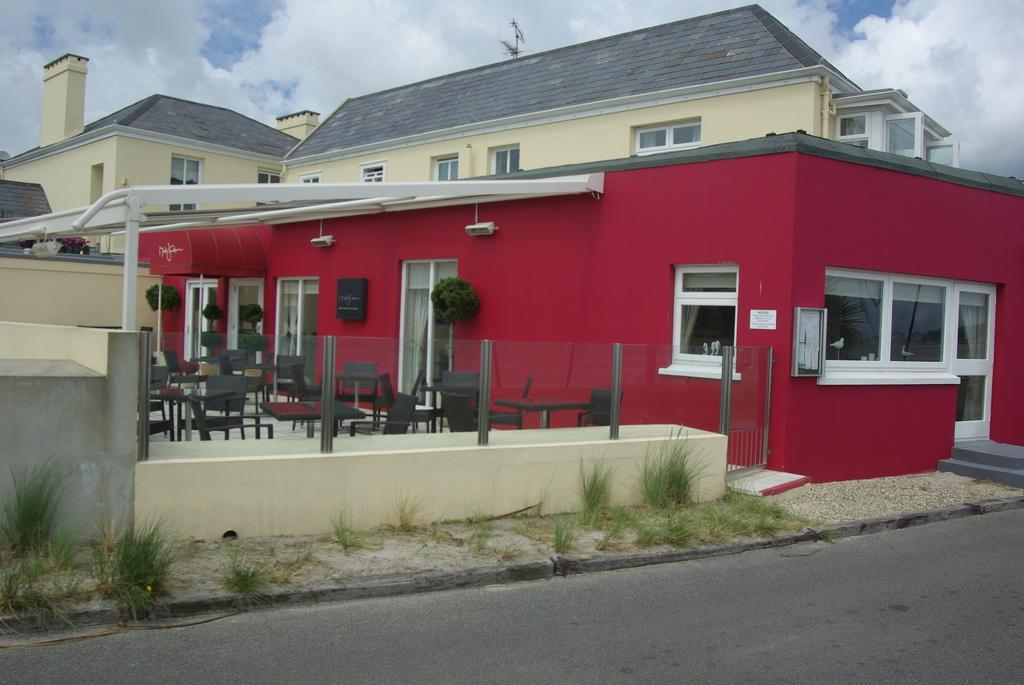What is the main structure in the center of the image? There is a building in the center of the image. What is located at the bottom of the image? There is a road at the bottom of the image. What type of vegetation can be seen in the image? Grass is visible in the image. What is visible at the top of the image? The sky is visible at the top of the image. How many dogs are sitting on the elbow in the image? There are no dogs or elbows present in the image. 